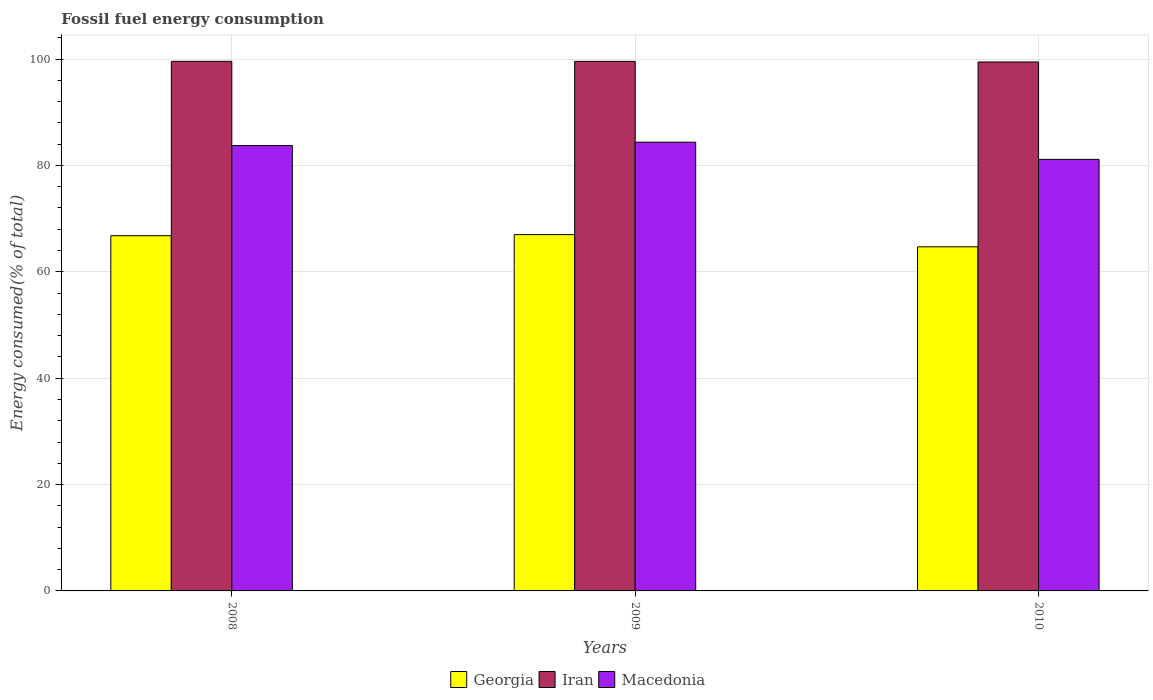How many different coloured bars are there?
Your response must be concise. 3. How many bars are there on the 1st tick from the left?
Provide a succinct answer. 3. How many bars are there on the 1st tick from the right?
Provide a short and direct response. 3. In how many cases, is the number of bars for a given year not equal to the number of legend labels?
Give a very brief answer. 0. What is the percentage of energy consumed in Macedonia in 2008?
Offer a terse response. 83.74. Across all years, what is the maximum percentage of energy consumed in Macedonia?
Offer a very short reply. 84.38. Across all years, what is the minimum percentage of energy consumed in Georgia?
Keep it short and to the point. 64.7. In which year was the percentage of energy consumed in Georgia maximum?
Provide a short and direct response. 2009. In which year was the percentage of energy consumed in Iran minimum?
Your answer should be compact. 2010. What is the total percentage of energy consumed in Macedonia in the graph?
Offer a terse response. 249.26. What is the difference between the percentage of energy consumed in Macedonia in 2008 and that in 2009?
Keep it short and to the point. -0.64. What is the difference between the percentage of energy consumed in Iran in 2010 and the percentage of energy consumed in Georgia in 2009?
Provide a short and direct response. 32.46. What is the average percentage of energy consumed in Georgia per year?
Your answer should be very brief. 66.16. In the year 2010, what is the difference between the percentage of energy consumed in Georgia and percentage of energy consumed in Iran?
Your answer should be very brief. -34.75. In how many years, is the percentage of energy consumed in Macedonia greater than 8 %?
Provide a short and direct response. 3. What is the ratio of the percentage of energy consumed in Georgia in 2008 to that in 2010?
Your response must be concise. 1.03. Is the percentage of energy consumed in Iran in 2008 less than that in 2009?
Your answer should be compact. No. What is the difference between the highest and the second highest percentage of energy consumed in Iran?
Give a very brief answer. 0.01. What is the difference between the highest and the lowest percentage of energy consumed in Iran?
Make the answer very short. 0.12. What does the 1st bar from the left in 2009 represents?
Offer a terse response. Georgia. What does the 2nd bar from the right in 2008 represents?
Offer a terse response. Iran. Are all the bars in the graph horizontal?
Provide a short and direct response. No. How many years are there in the graph?
Your answer should be compact. 3. Does the graph contain any zero values?
Make the answer very short. No. Does the graph contain grids?
Give a very brief answer. Yes. How are the legend labels stacked?
Make the answer very short. Horizontal. What is the title of the graph?
Your answer should be very brief. Fossil fuel energy consumption. What is the label or title of the Y-axis?
Give a very brief answer. Energy consumed(% of total). What is the Energy consumed(% of total) in Georgia in 2008?
Ensure brevity in your answer.  66.79. What is the Energy consumed(% of total) in Iran in 2008?
Offer a very short reply. 99.57. What is the Energy consumed(% of total) of Macedonia in 2008?
Your response must be concise. 83.74. What is the Energy consumed(% of total) of Georgia in 2009?
Offer a very short reply. 66.99. What is the Energy consumed(% of total) of Iran in 2009?
Provide a short and direct response. 99.56. What is the Energy consumed(% of total) of Macedonia in 2009?
Offer a terse response. 84.38. What is the Energy consumed(% of total) in Georgia in 2010?
Provide a short and direct response. 64.7. What is the Energy consumed(% of total) of Iran in 2010?
Offer a very short reply. 99.45. What is the Energy consumed(% of total) in Macedonia in 2010?
Provide a succinct answer. 81.14. Across all years, what is the maximum Energy consumed(% of total) of Georgia?
Offer a very short reply. 66.99. Across all years, what is the maximum Energy consumed(% of total) in Iran?
Keep it short and to the point. 99.57. Across all years, what is the maximum Energy consumed(% of total) in Macedonia?
Make the answer very short. 84.38. Across all years, what is the minimum Energy consumed(% of total) in Georgia?
Provide a succinct answer. 64.7. Across all years, what is the minimum Energy consumed(% of total) of Iran?
Your answer should be compact. 99.45. Across all years, what is the minimum Energy consumed(% of total) in Macedonia?
Ensure brevity in your answer.  81.14. What is the total Energy consumed(% of total) in Georgia in the graph?
Keep it short and to the point. 198.49. What is the total Energy consumed(% of total) in Iran in the graph?
Offer a very short reply. 298.59. What is the total Energy consumed(% of total) in Macedonia in the graph?
Your answer should be very brief. 249.26. What is the difference between the Energy consumed(% of total) of Georgia in 2008 and that in 2009?
Offer a terse response. -0.2. What is the difference between the Energy consumed(% of total) in Iran in 2008 and that in 2009?
Provide a succinct answer. 0.01. What is the difference between the Energy consumed(% of total) of Macedonia in 2008 and that in 2009?
Provide a succinct answer. -0.64. What is the difference between the Energy consumed(% of total) in Georgia in 2008 and that in 2010?
Give a very brief answer. 2.09. What is the difference between the Energy consumed(% of total) in Iran in 2008 and that in 2010?
Offer a terse response. 0.12. What is the difference between the Energy consumed(% of total) in Macedonia in 2008 and that in 2010?
Keep it short and to the point. 2.6. What is the difference between the Energy consumed(% of total) in Georgia in 2009 and that in 2010?
Your answer should be very brief. 2.29. What is the difference between the Energy consumed(% of total) of Iran in 2009 and that in 2010?
Keep it short and to the point. 0.11. What is the difference between the Energy consumed(% of total) in Macedonia in 2009 and that in 2010?
Ensure brevity in your answer.  3.23. What is the difference between the Energy consumed(% of total) in Georgia in 2008 and the Energy consumed(% of total) in Iran in 2009?
Ensure brevity in your answer.  -32.77. What is the difference between the Energy consumed(% of total) in Georgia in 2008 and the Energy consumed(% of total) in Macedonia in 2009?
Offer a very short reply. -17.59. What is the difference between the Energy consumed(% of total) in Iran in 2008 and the Energy consumed(% of total) in Macedonia in 2009?
Make the answer very short. 15.2. What is the difference between the Energy consumed(% of total) in Georgia in 2008 and the Energy consumed(% of total) in Iran in 2010?
Your answer should be very brief. -32.66. What is the difference between the Energy consumed(% of total) of Georgia in 2008 and the Energy consumed(% of total) of Macedonia in 2010?
Keep it short and to the point. -14.35. What is the difference between the Energy consumed(% of total) in Iran in 2008 and the Energy consumed(% of total) in Macedonia in 2010?
Your answer should be very brief. 18.43. What is the difference between the Energy consumed(% of total) in Georgia in 2009 and the Energy consumed(% of total) in Iran in 2010?
Ensure brevity in your answer.  -32.46. What is the difference between the Energy consumed(% of total) of Georgia in 2009 and the Energy consumed(% of total) of Macedonia in 2010?
Your answer should be very brief. -14.15. What is the difference between the Energy consumed(% of total) of Iran in 2009 and the Energy consumed(% of total) of Macedonia in 2010?
Your answer should be compact. 18.42. What is the average Energy consumed(% of total) in Georgia per year?
Offer a terse response. 66.16. What is the average Energy consumed(% of total) of Iran per year?
Ensure brevity in your answer.  99.53. What is the average Energy consumed(% of total) in Macedonia per year?
Offer a very short reply. 83.09. In the year 2008, what is the difference between the Energy consumed(% of total) of Georgia and Energy consumed(% of total) of Iran?
Provide a succinct answer. -32.78. In the year 2008, what is the difference between the Energy consumed(% of total) of Georgia and Energy consumed(% of total) of Macedonia?
Ensure brevity in your answer.  -16.95. In the year 2008, what is the difference between the Energy consumed(% of total) in Iran and Energy consumed(% of total) in Macedonia?
Keep it short and to the point. 15.83. In the year 2009, what is the difference between the Energy consumed(% of total) in Georgia and Energy consumed(% of total) in Iran?
Ensure brevity in your answer.  -32.57. In the year 2009, what is the difference between the Energy consumed(% of total) of Georgia and Energy consumed(% of total) of Macedonia?
Make the answer very short. -17.38. In the year 2009, what is the difference between the Energy consumed(% of total) of Iran and Energy consumed(% of total) of Macedonia?
Provide a succinct answer. 15.19. In the year 2010, what is the difference between the Energy consumed(% of total) in Georgia and Energy consumed(% of total) in Iran?
Your answer should be very brief. -34.75. In the year 2010, what is the difference between the Energy consumed(% of total) in Georgia and Energy consumed(% of total) in Macedonia?
Ensure brevity in your answer.  -16.44. In the year 2010, what is the difference between the Energy consumed(% of total) of Iran and Energy consumed(% of total) of Macedonia?
Ensure brevity in your answer.  18.31. What is the ratio of the Energy consumed(% of total) in Iran in 2008 to that in 2009?
Your answer should be very brief. 1. What is the ratio of the Energy consumed(% of total) in Georgia in 2008 to that in 2010?
Your answer should be compact. 1.03. What is the ratio of the Energy consumed(% of total) in Iran in 2008 to that in 2010?
Your answer should be very brief. 1. What is the ratio of the Energy consumed(% of total) in Macedonia in 2008 to that in 2010?
Offer a very short reply. 1.03. What is the ratio of the Energy consumed(% of total) of Georgia in 2009 to that in 2010?
Keep it short and to the point. 1.04. What is the ratio of the Energy consumed(% of total) of Iran in 2009 to that in 2010?
Offer a terse response. 1. What is the ratio of the Energy consumed(% of total) in Macedonia in 2009 to that in 2010?
Offer a terse response. 1.04. What is the difference between the highest and the second highest Energy consumed(% of total) in Georgia?
Provide a short and direct response. 0.2. What is the difference between the highest and the second highest Energy consumed(% of total) of Iran?
Your answer should be very brief. 0.01. What is the difference between the highest and the second highest Energy consumed(% of total) of Macedonia?
Your response must be concise. 0.64. What is the difference between the highest and the lowest Energy consumed(% of total) in Georgia?
Provide a succinct answer. 2.29. What is the difference between the highest and the lowest Energy consumed(% of total) in Iran?
Keep it short and to the point. 0.12. What is the difference between the highest and the lowest Energy consumed(% of total) of Macedonia?
Your answer should be very brief. 3.23. 